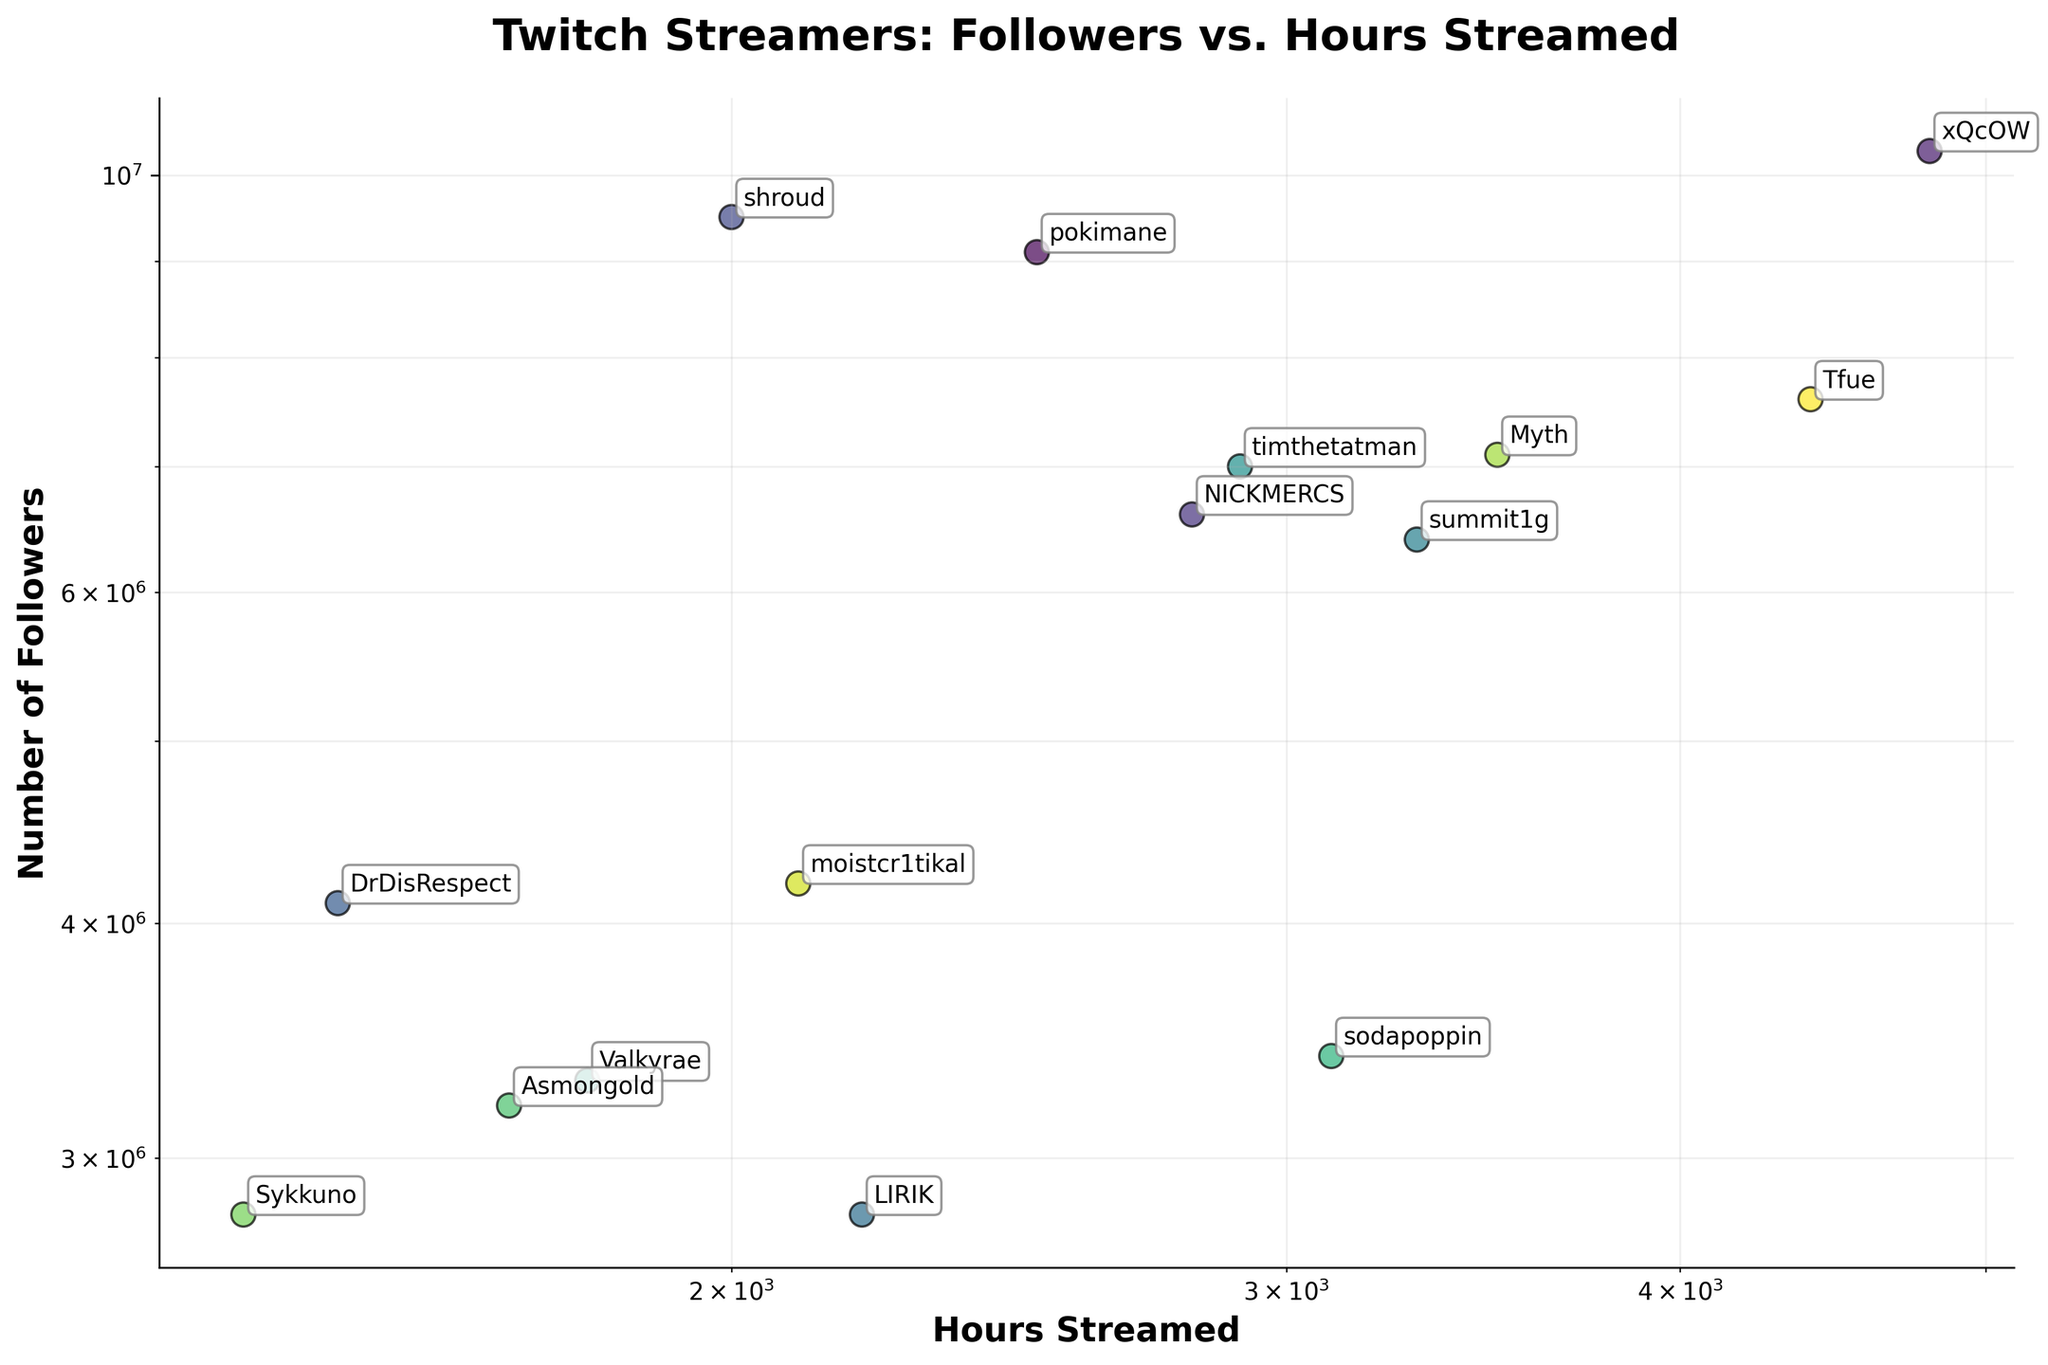What is the title of the plot? The title is displayed at the top center of the plot. It gives an overview of what the plot represents.
Answer: Twitch Streamers: Followers vs. Hours Streamed Which streamer has the most followers? Look for the data point that is furthest upward on the vertical axis (Number of Followers).
Answer: xQcOW Which streamer has the fewest hours streamed? Look for the data point on the x-axis (Hours Streamed) that is closest to the left.
Answer: Sykkuno How many streamers are plotted in the figure? Count the number of annotated data points on the scatter plot.
Answer: 15 Which streamers have streamed more than 3000 hours? Identify data points with x-values (Hours Streamed) above 3000 and annotate them.
Answer: xQcOW, summit1g, Myth, sodapoppin, Tfue How many followers does DrDisRespect have? Locate the data point labeled DrDisRespect and refer to its y-value (Number of Followers).
Answer: 4100000 Is there a positive correlation between the number of followers and hours streamed? Assess whether, in general, as the x-values increase, the y-values also increase on the log-log plot.
Answer: Yes Which streamer has streamed the most hours but has fewer than 5 million followers? Identify the point with the highest x-value (Hours Streamed) and a y-value (Number of Followers) less than 5000000.
Answer: Myth Who has more followers: shroud or timthetatman? Compare the y-values (Number of Followers) of the data points labeled shroud and timthetatman.
Answer: shroud What is the follower difference between xQcOW and pokimane? Calculate the difference between the y-values (Number of Followers) of data points labeled xQcOW and pokimane.
Answer: 1200000 